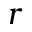<formula> <loc_0><loc_0><loc_500><loc_500>r</formula> 